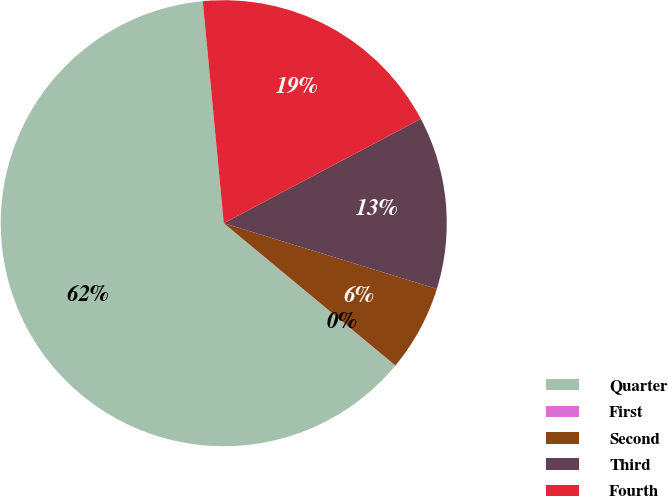Convert chart. <chart><loc_0><loc_0><loc_500><loc_500><pie_chart><fcel>Quarter<fcel>First<fcel>Second<fcel>Third<fcel>Fourth<nl><fcel>62.46%<fcel>0.02%<fcel>6.26%<fcel>12.51%<fcel>18.75%<nl></chart> 